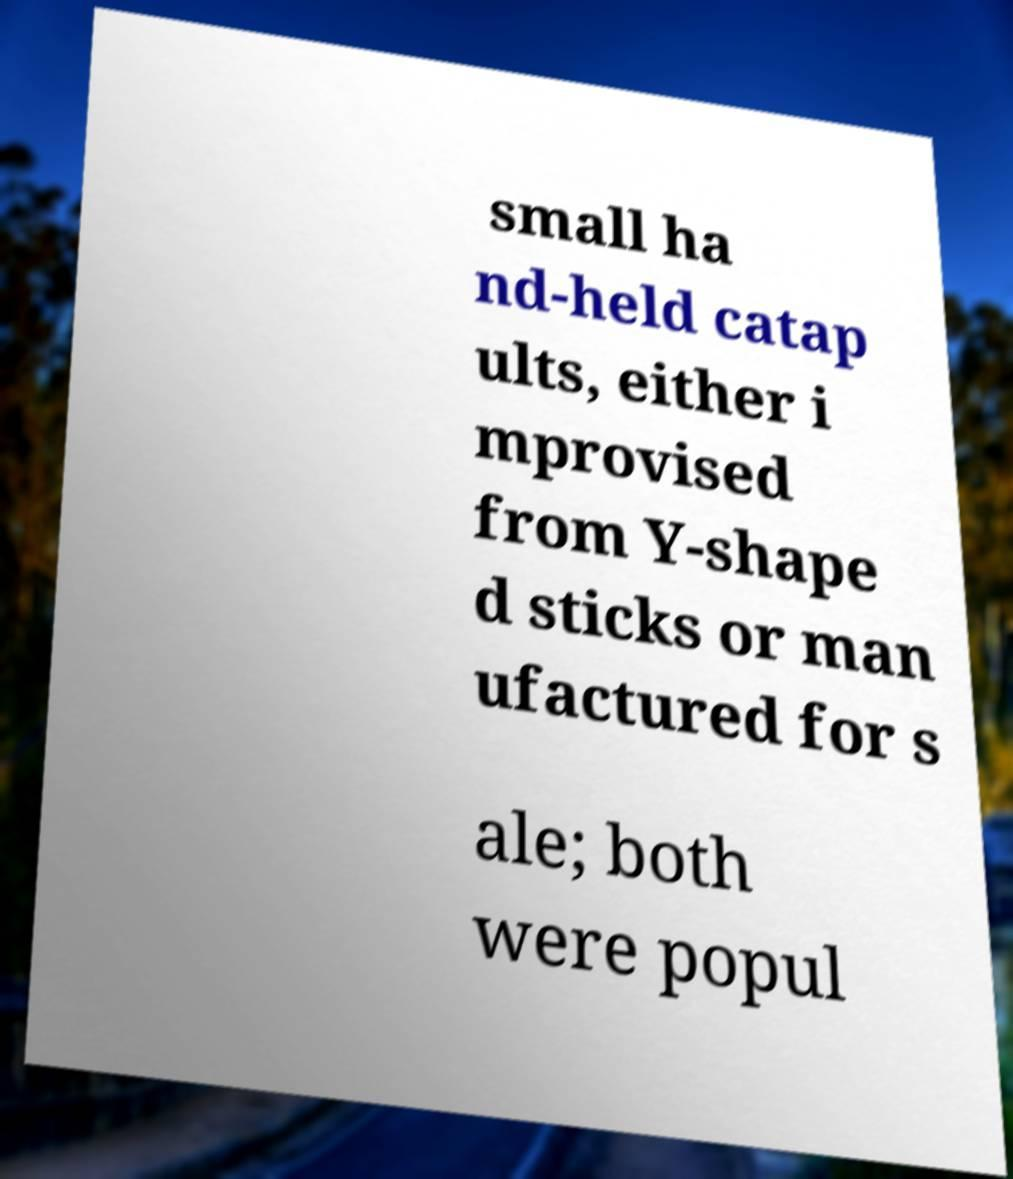Could you extract and type out the text from this image? small ha nd-held catap ults, either i mprovised from Y-shape d sticks or man ufactured for s ale; both were popul 